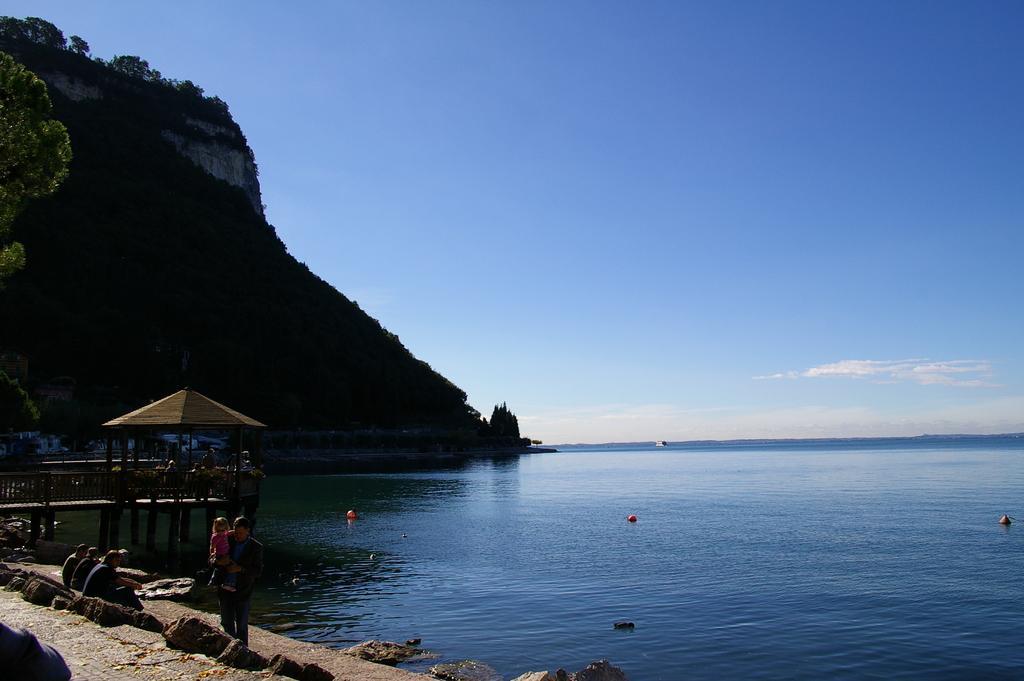Could you give a brief overview of what you see in this image? In this image there is a sea on the left side there are people sitting in the beach and people standing there is a hut, in the background there is a mountain. 